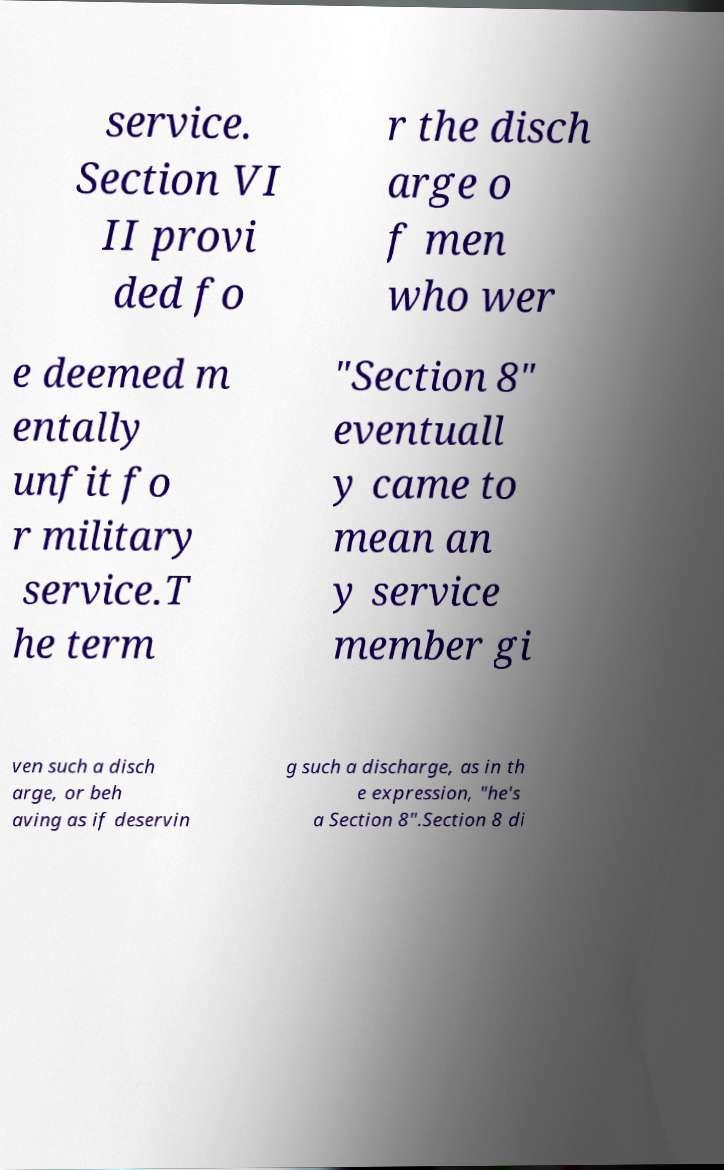Could you extract and type out the text from this image? service. Section VI II provi ded fo r the disch arge o f men who wer e deemed m entally unfit fo r military service.T he term "Section 8" eventuall y came to mean an y service member gi ven such a disch arge, or beh aving as if deservin g such a discharge, as in th e expression, "he's a Section 8".Section 8 di 